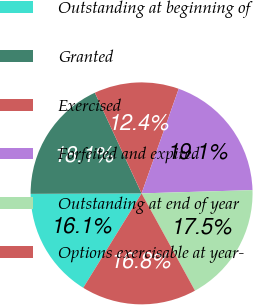<chart> <loc_0><loc_0><loc_500><loc_500><pie_chart><fcel>Outstanding at beginning of<fcel>Granted<fcel>Exercised<fcel>Forfeited and expired<fcel>Outstanding at end of year<fcel>Options exercisable at year-<nl><fcel>16.12%<fcel>18.15%<fcel>12.35%<fcel>19.1%<fcel>17.48%<fcel>16.8%<nl></chart> 